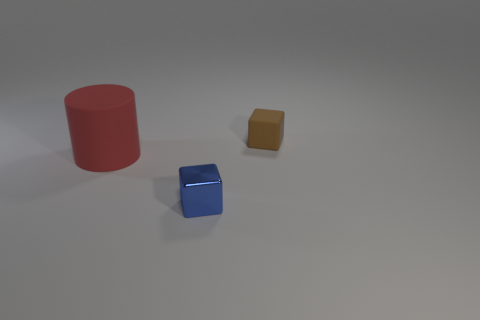Add 2 big blue metallic cubes. How many objects exist? 5 Subtract all cubes. How many objects are left? 1 Add 3 tiny metallic cubes. How many tiny metallic cubes exist? 4 Subtract 0 purple blocks. How many objects are left? 3 Subtract all tiny blue metal things. Subtract all large purple matte objects. How many objects are left? 2 Add 3 matte cylinders. How many matte cylinders are left? 4 